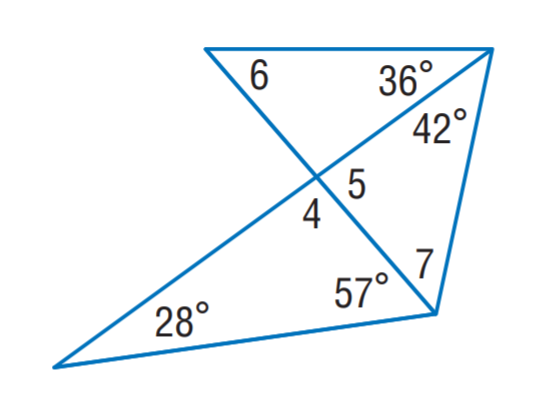Answer the mathemtical geometry problem and directly provide the correct option letter.
Question: Find m \angle 5.
Choices: A: 53 B: 75 C: 85 D: 88 C 